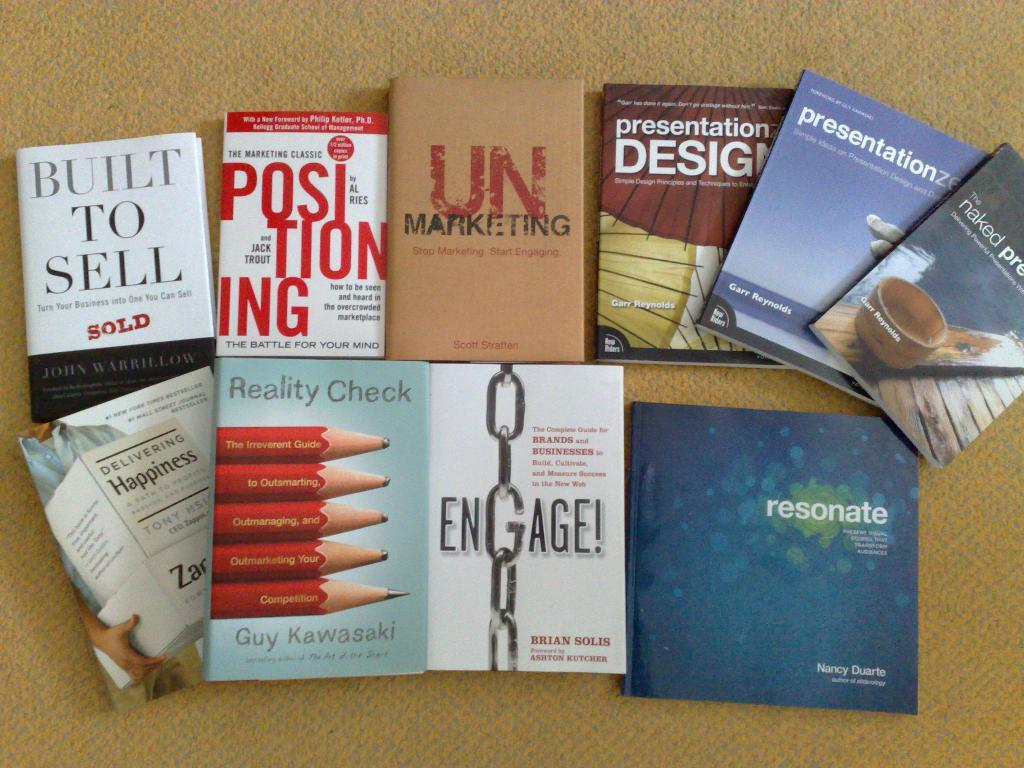<image>
Relay a brief, clear account of the picture shown. Various business books are lined up in two rows, including Built to Sell. 